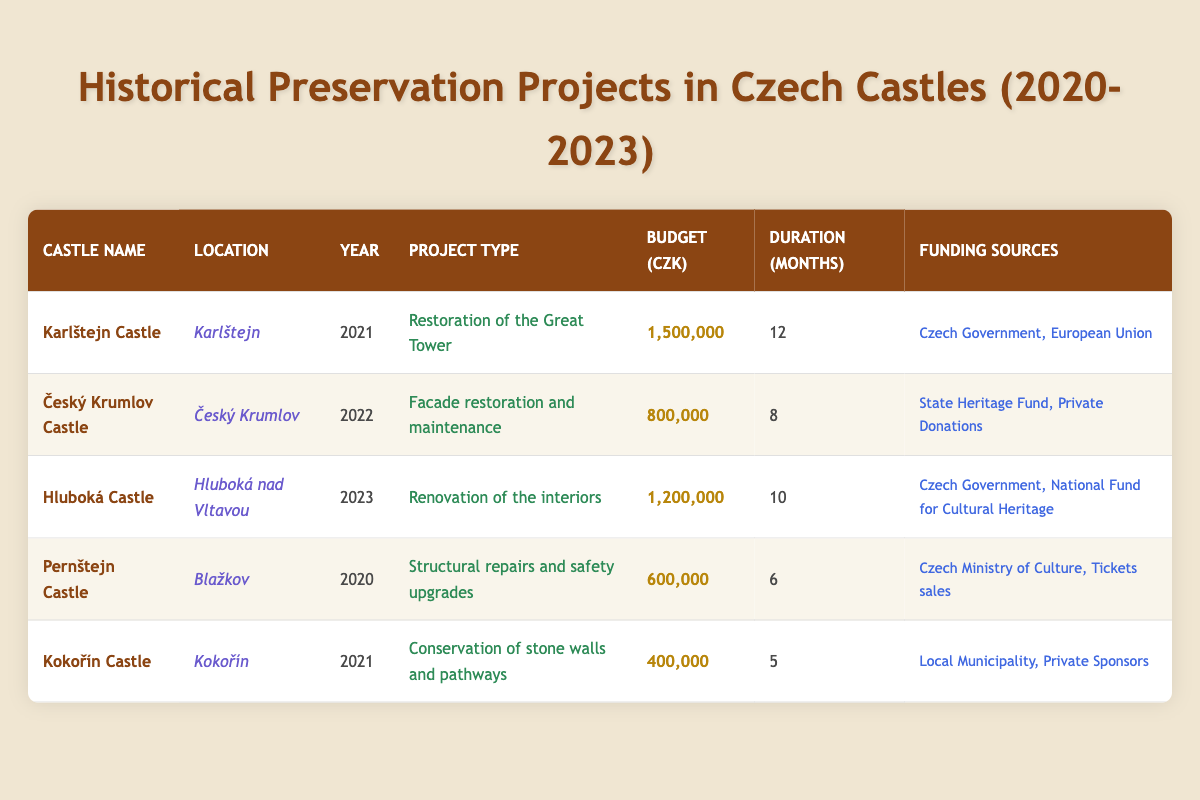What is the budget for the restoration of the Great Tower at Karlštejn Castle? The budget is stated directly in the table under the "Budget (CZK)" column for Karlštejn Castle in the year 2021, which is 1,500,000 CZK.
Answer: 1,500,000 CZK How long did the facade restoration and maintenance project at Český Krumlov Castle take? The duration of the project is given in the table under the "Duration (Months)" column for Český Krumlov Castle in the year 2022, which is 8 months.
Answer: 8 months Which castle had the lowest budget for its preservation project and what was the amount? By comparing the budgets listed in the "Budget (CZK)" column, Kokořín Castle has the lowest budget at 400,000 CZK.
Answer: Kokořín Castle, 400,000 CZK Did the funding for Hluboká Castle's renovation come from private donations? The funding sources for Hluboká Castle in 2023 include the Czech Government and the National Fund for Cultural Heritage, and there are no private donations listed.
Answer: No What is the total budget for all projects listed in the table? To find the total budget, add the budgets from each project: 1,500,000 + 800,000 + 1,200,000 + 600,000 + 400,000 = 4,500,000 CZK.
Answer: 4,500,000 CZK How many months did the conservation of stone walls and pathways at Kokořín Castle take compared to the duration of the renovation of interiors at Hluboká Castle? The duration for Kokořín Castle is 5 months, while for Hluboká Castle it is 10 months. So, Hluboká Castle's project took 5 months longer than Kokořín Castle's.
Answer: 5 months longer Which castle project was funded by both the Czech Government and the European Union? By checking the funding sources, Karlštejn Castle in 2021 is the only project that was funded by both the Czech Government and the European Union.
Answer: Karlštejn Castle Is there a project listed in the table for Český Krumlov Castle in 2023? The table includes project information only until 2023, and for Český Krumlov Castle, the project year is 2022. Thus, there is no project listed for 2023.
Answer: No 